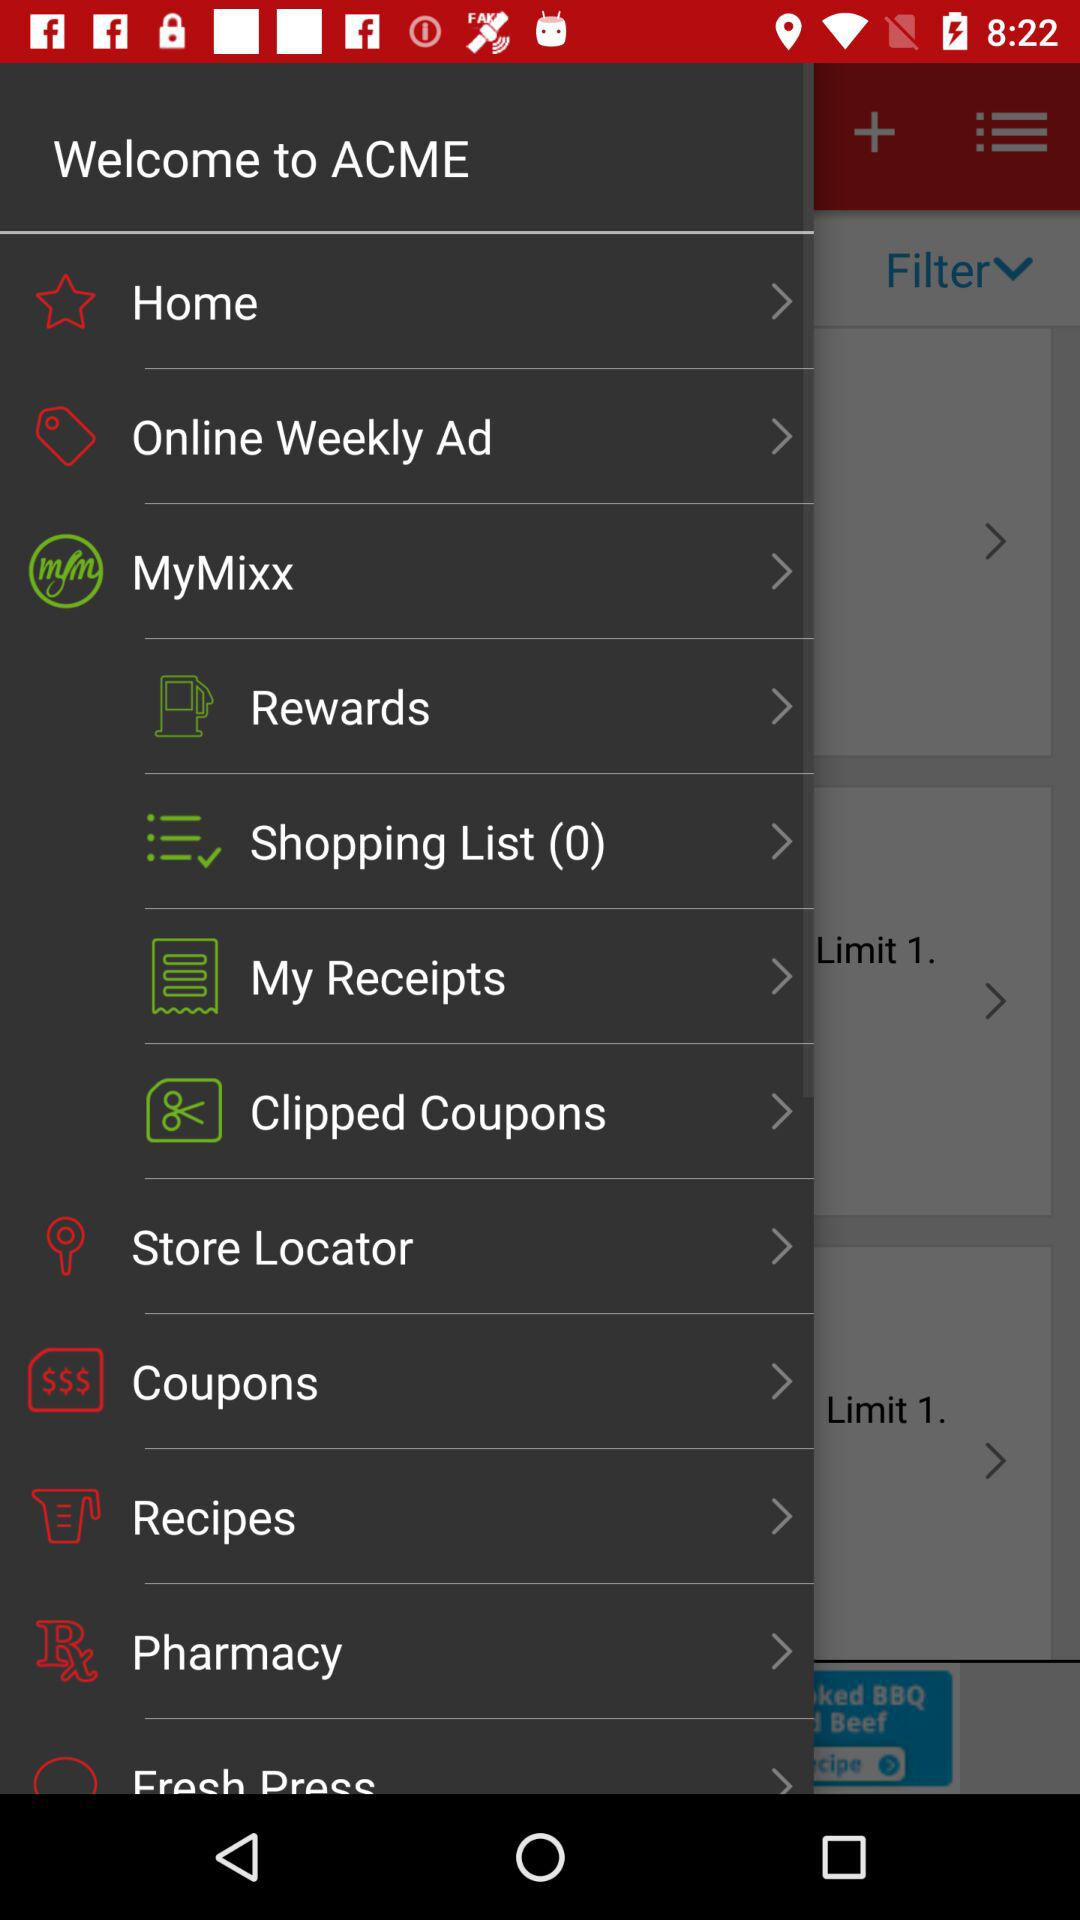What is the name of the application? The name of the application is "ACME". 